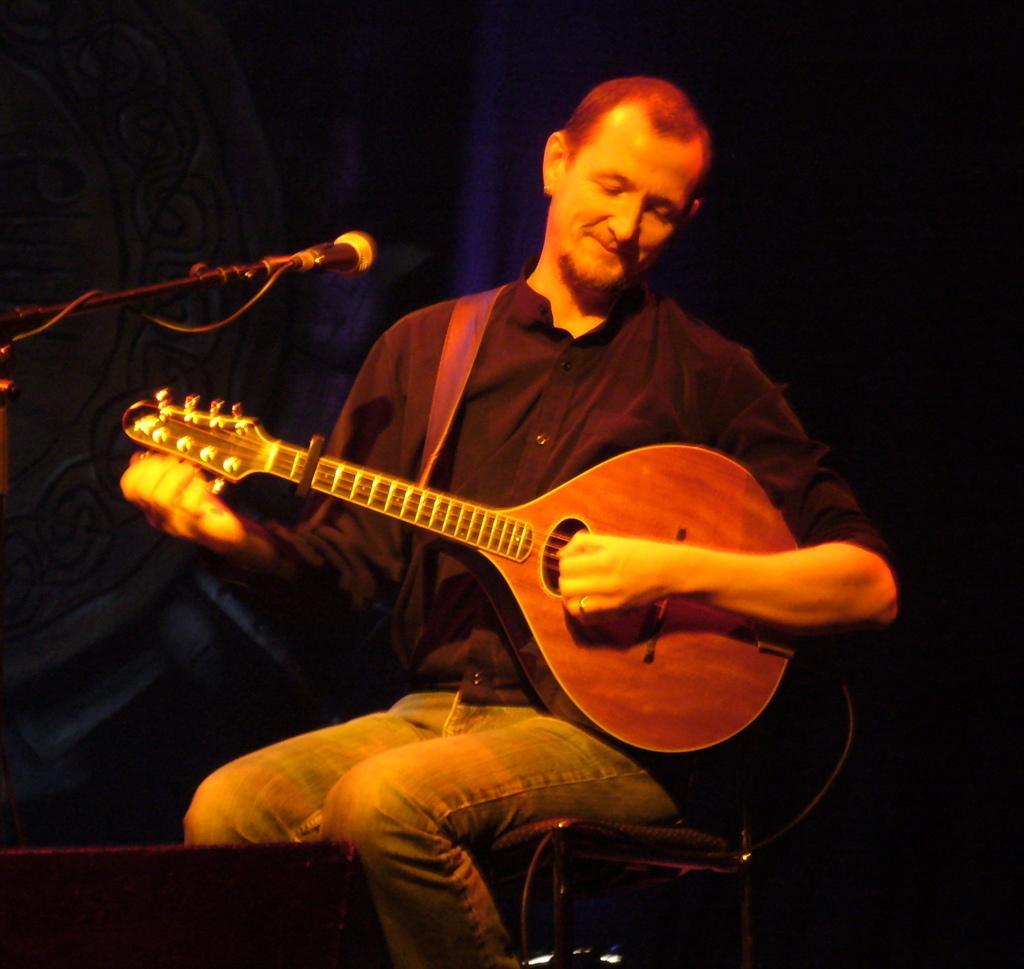How would you summarize this image in a sentence or two? The image consist of a man playing guitar. He is wearing blue shirt and jeans pant. In the background, there is a blue cloth. To the left, there is a mic with mic stand. At the bottom, there is a chair on which the man is sitting. 